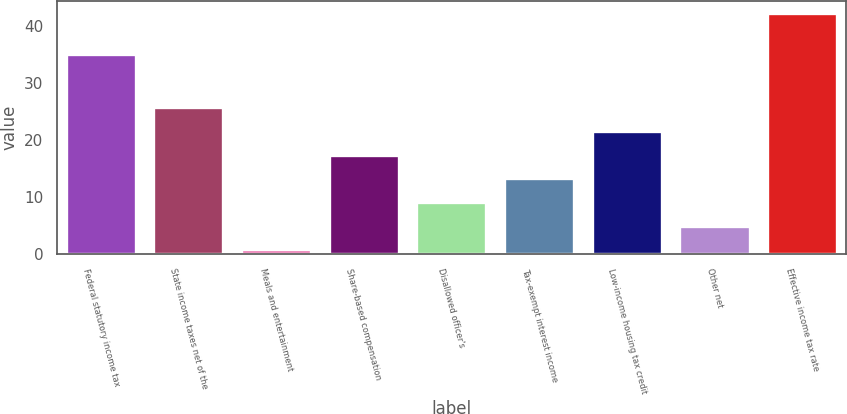Convert chart to OTSL. <chart><loc_0><loc_0><loc_500><loc_500><bar_chart><fcel>Federal statutory income tax<fcel>State income taxes net of the<fcel>Meals and entertainment<fcel>Share-based compensation<fcel>Disallowed officer's<fcel>Tax-exempt interest income<fcel>Low-income housing tax credit<fcel>Other net<fcel>Effective income tax rate<nl><fcel>35<fcel>25.74<fcel>0.9<fcel>17.46<fcel>9.18<fcel>13.32<fcel>21.6<fcel>5.04<fcel>42.3<nl></chart> 